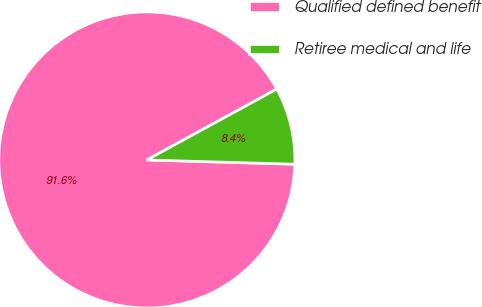Convert chart. <chart><loc_0><loc_0><loc_500><loc_500><pie_chart><fcel>Qualified defined benefit<fcel>Retiree medical and life<nl><fcel>91.59%<fcel>8.41%<nl></chart> 